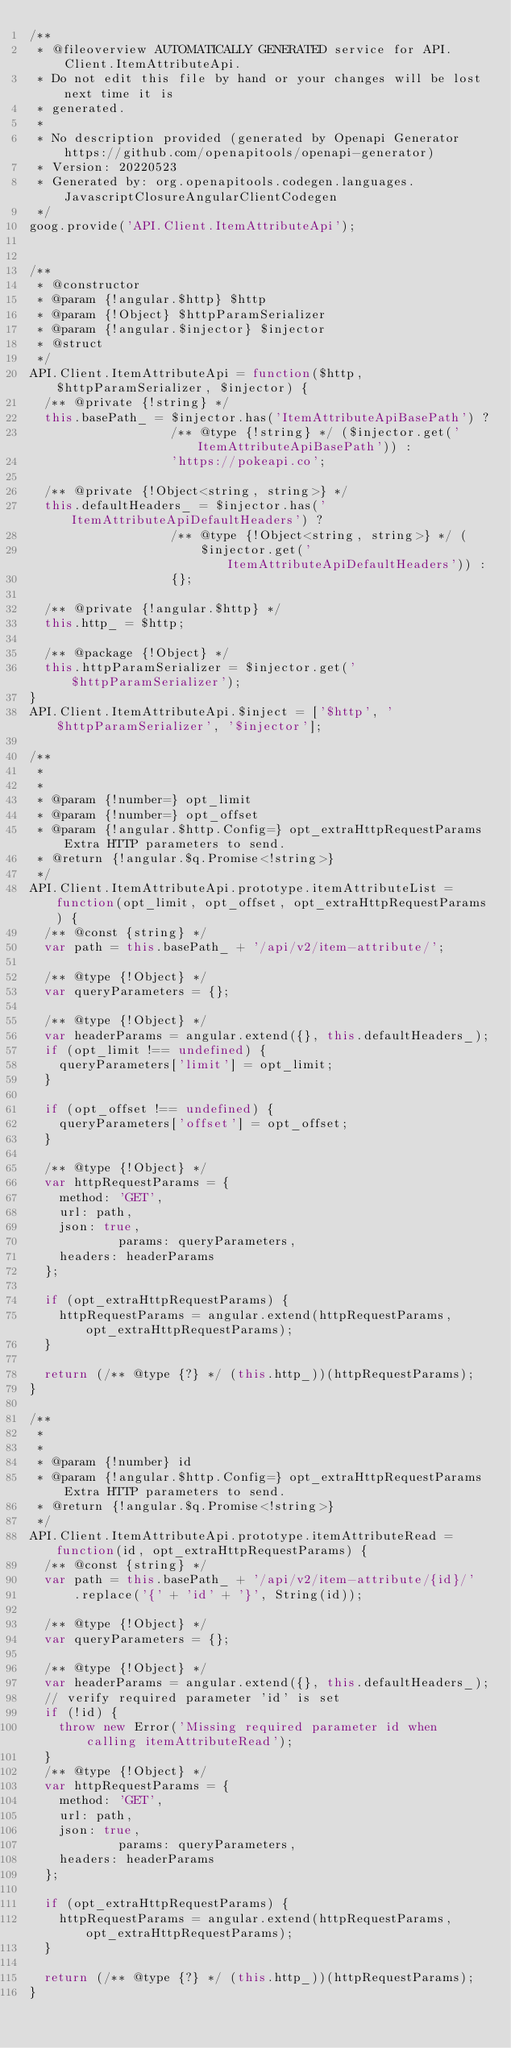Convert code to text. <code><loc_0><loc_0><loc_500><loc_500><_JavaScript_>/**
 * @fileoverview AUTOMATICALLY GENERATED service for API.Client.ItemAttributeApi.
 * Do not edit this file by hand or your changes will be lost next time it is
 * generated.
 *
 * No description provided (generated by Openapi Generator https://github.com/openapitools/openapi-generator)
 * Version: 20220523
 * Generated by: org.openapitools.codegen.languages.JavascriptClosureAngularClientCodegen
 */
goog.provide('API.Client.ItemAttributeApi');


/**
 * @constructor
 * @param {!angular.$http} $http
 * @param {!Object} $httpParamSerializer
 * @param {!angular.$injector} $injector
 * @struct
 */
API.Client.ItemAttributeApi = function($http, $httpParamSerializer, $injector) {
  /** @private {!string} */
  this.basePath_ = $injector.has('ItemAttributeApiBasePath') ?
                   /** @type {!string} */ ($injector.get('ItemAttributeApiBasePath')) :
                   'https://pokeapi.co';

  /** @private {!Object<string, string>} */
  this.defaultHeaders_ = $injector.has('ItemAttributeApiDefaultHeaders') ?
                   /** @type {!Object<string, string>} */ (
                       $injector.get('ItemAttributeApiDefaultHeaders')) :
                   {};

  /** @private {!angular.$http} */
  this.http_ = $http;

  /** @package {!Object} */
  this.httpParamSerializer = $injector.get('$httpParamSerializer');
}
API.Client.ItemAttributeApi.$inject = ['$http', '$httpParamSerializer', '$injector'];

/**
 * 
 * 
 * @param {!number=} opt_limit 
 * @param {!number=} opt_offset 
 * @param {!angular.$http.Config=} opt_extraHttpRequestParams Extra HTTP parameters to send.
 * @return {!angular.$q.Promise<!string>}
 */
API.Client.ItemAttributeApi.prototype.itemAttributeList = function(opt_limit, opt_offset, opt_extraHttpRequestParams) {
  /** @const {string} */
  var path = this.basePath_ + '/api/v2/item-attribute/';

  /** @type {!Object} */
  var queryParameters = {};

  /** @type {!Object} */
  var headerParams = angular.extend({}, this.defaultHeaders_);
  if (opt_limit !== undefined) {
    queryParameters['limit'] = opt_limit;
  }

  if (opt_offset !== undefined) {
    queryParameters['offset'] = opt_offset;
  }

  /** @type {!Object} */
  var httpRequestParams = {
    method: 'GET',
    url: path,
    json: true,
            params: queryParameters,
    headers: headerParams
  };

  if (opt_extraHttpRequestParams) {
    httpRequestParams = angular.extend(httpRequestParams, opt_extraHttpRequestParams);
  }

  return (/** @type {?} */ (this.http_))(httpRequestParams);
}

/**
 * 
 * 
 * @param {!number} id 
 * @param {!angular.$http.Config=} opt_extraHttpRequestParams Extra HTTP parameters to send.
 * @return {!angular.$q.Promise<!string>}
 */
API.Client.ItemAttributeApi.prototype.itemAttributeRead = function(id, opt_extraHttpRequestParams) {
  /** @const {string} */
  var path = this.basePath_ + '/api/v2/item-attribute/{id}/'
      .replace('{' + 'id' + '}', String(id));

  /** @type {!Object} */
  var queryParameters = {};

  /** @type {!Object} */
  var headerParams = angular.extend({}, this.defaultHeaders_);
  // verify required parameter 'id' is set
  if (!id) {
    throw new Error('Missing required parameter id when calling itemAttributeRead');
  }
  /** @type {!Object} */
  var httpRequestParams = {
    method: 'GET',
    url: path,
    json: true,
            params: queryParameters,
    headers: headerParams
  };

  if (opt_extraHttpRequestParams) {
    httpRequestParams = angular.extend(httpRequestParams, opt_extraHttpRequestParams);
  }

  return (/** @type {?} */ (this.http_))(httpRequestParams);
}
</code> 